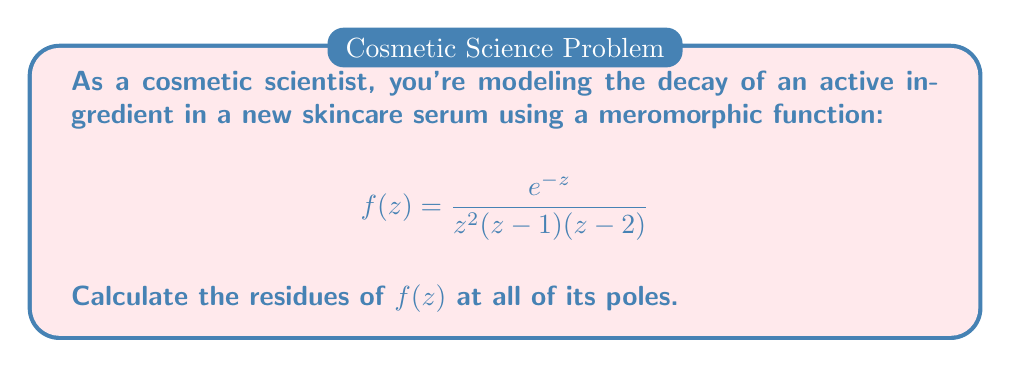Solve this math problem. Let's approach this step-by-step:

1) First, we identify the poles of $f(z)$. They are:
   - $z = 0$ (order 2)
   - $z = 1$ (order 1)
   - $z = 2$ (order 1)

2) For $z = 0$ (order 2 pole):
   We use the formula for the residue of an order 2 pole:
   $$\text{Res}(f,0) = \lim_{z \to 0} \frac{d}{dz}\left[z^2f(z)\right]$$
   
   $$\begin{align}
   \text{Res}(f,0) &= \lim_{z \to 0} \frac{d}{dz}\left[\frac{e^{-z}}{(z-1)(z-2)}\right] \\
   &= \lim_{z \to 0} \frac{-e^{-z}(z-1)(z-2) - e^{-z}(2z-3)}{(z-1)^2(z-2)^2} \\
   &= \frac{-1(0-1)(0-2) - 1(0-3)}{(0-1)^2(0-2)^2} \\
   &= \frac{2+3}{4} = \frac{5}{4}
   \end{align}$$

3) For $z = 1$ (simple pole):
   We use the formula for the residue of a simple pole:
   $$\text{Res}(f,1) = \lim_{z \to 1} (z-1)f(z)$$
   
   $$\begin{align}
   \text{Res}(f,1) &= \lim_{z \to 1} (z-1)\frac{e^{-z}}{z^2(z-1)(z-2)} \\
   &= \lim_{z \to 1} \frac{e^{-z}}{z^2(z-2)} \\
   &= \frac{e^{-1}}{1^2(1-2)} = -\frac{e^{-1}}{1} = -e^{-1}
   \end{align}$$

4) For $z = 2$ (simple pole):
   Similar to $z = 1$:
   $$\text{Res}(f,2) = \lim_{z \to 2} (z-2)f(z)$$
   
   $$\begin{align}
   \text{Res}(f,2) &= \lim_{z \to 2} (z-2)\frac{e^{-z}}{z^2(z-1)(z-2)} \\
   &= \lim_{z \to 2} \frac{e^{-z}}{z^2(z-1)} \\
   &= \frac{e^{-2}}{2^2(2-1)} = \frac{e^{-2}}{4}
   \end{align}$$
Answer: $\text{Res}(f,0) = \frac{5}{4}$, $\text{Res}(f,1) = -e^{-1}$, $\text{Res}(f,2) = \frac{e^{-2}}{4}$ 